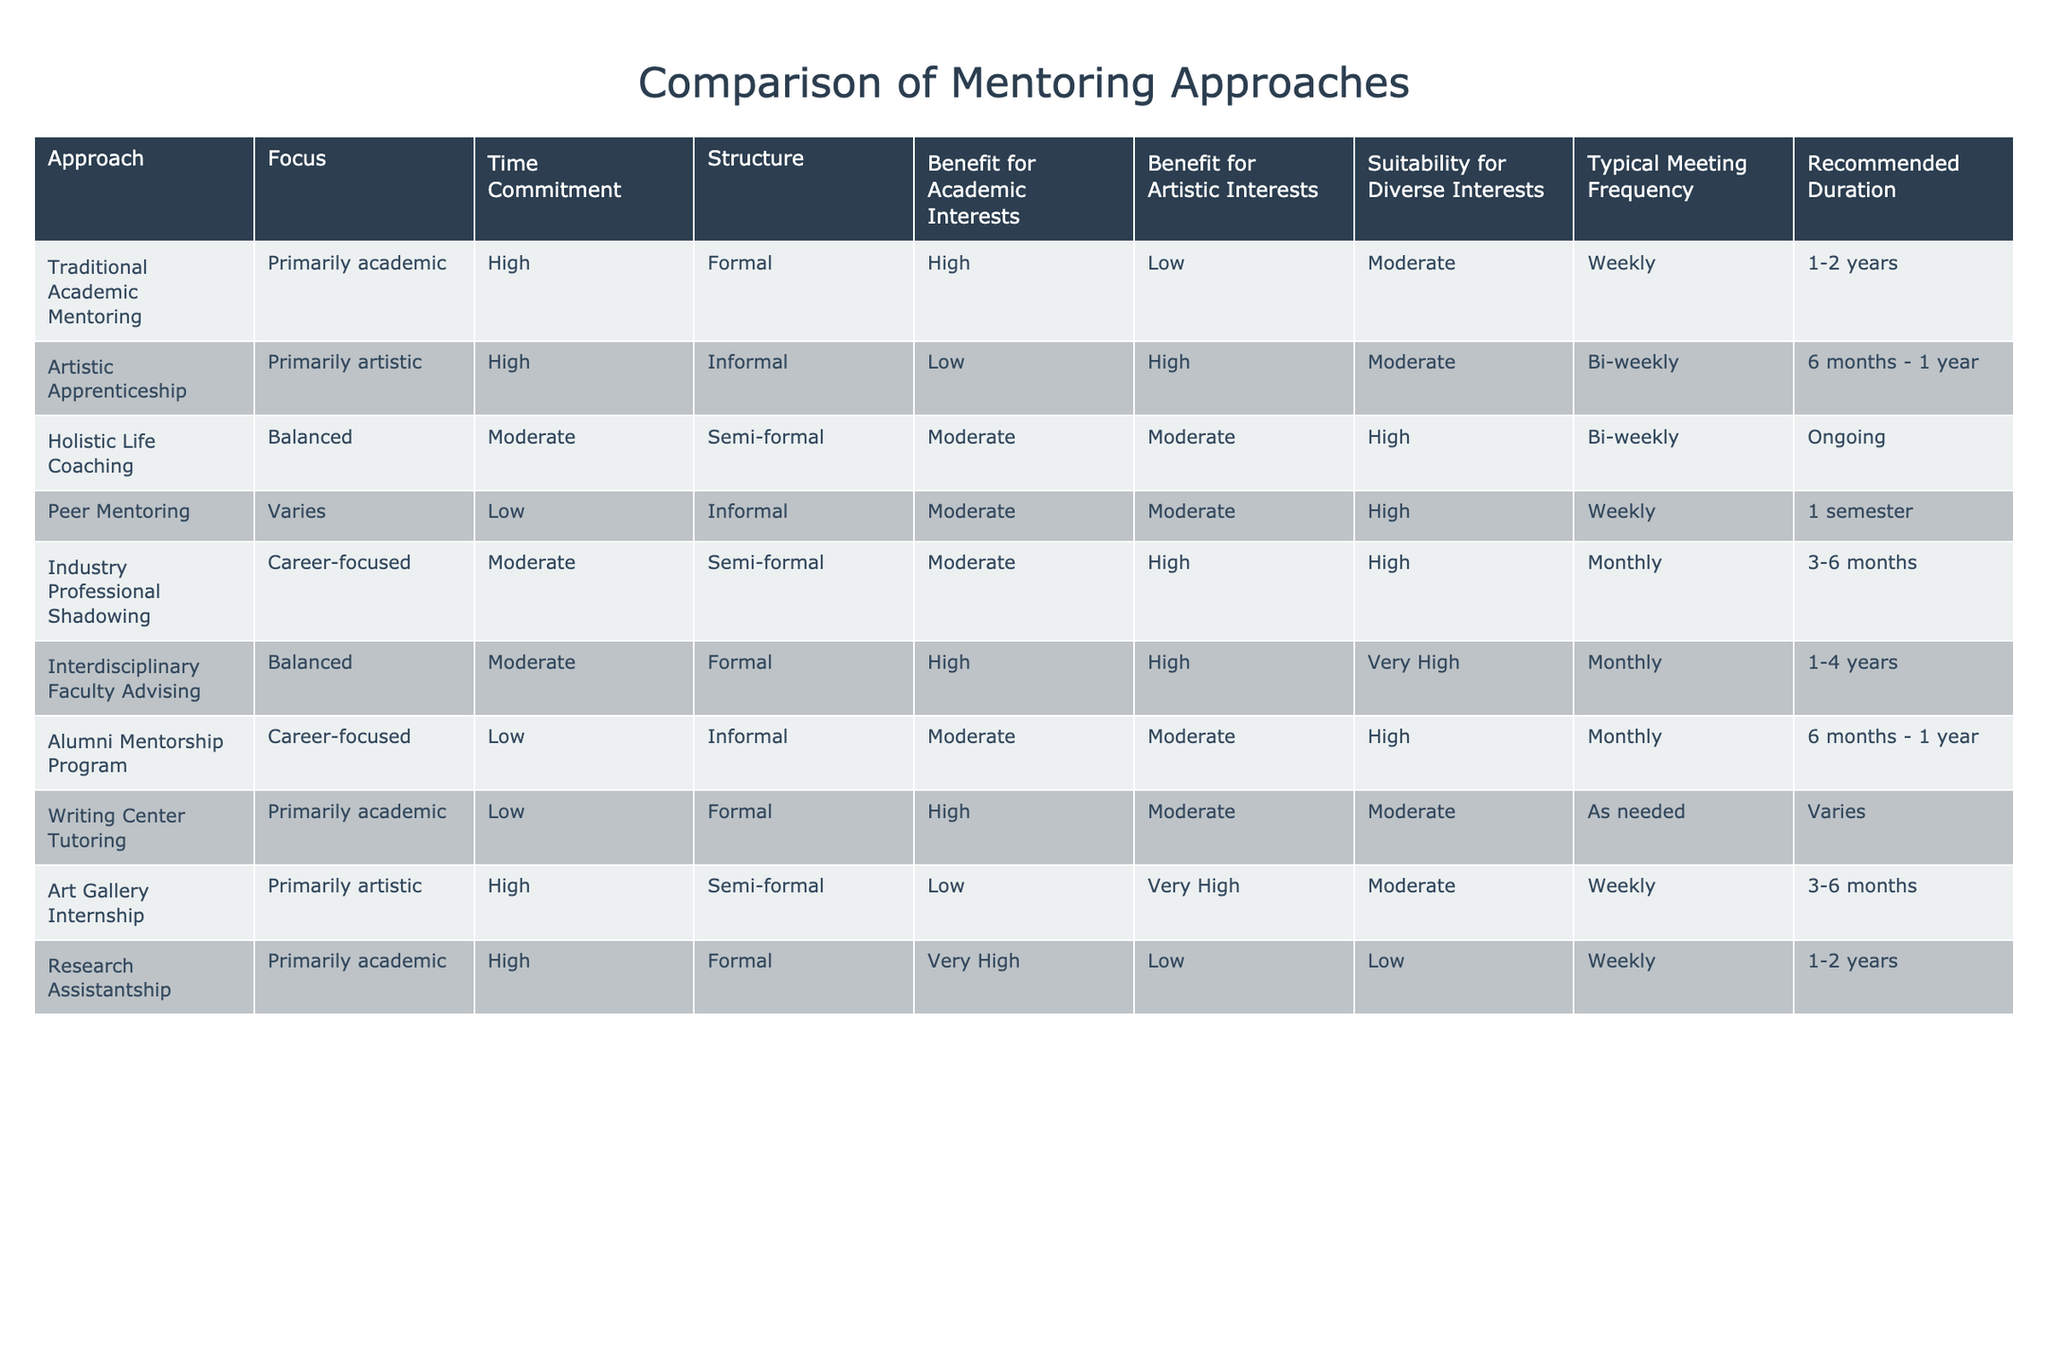What is the typical meeting frequency for Peer Mentoring? Looking at the "Typical Meeting Frequency" column, Peer Mentoring is listed with a frequency of "Weekly."
Answer: Weekly Which mentoring approach has the highest benefit for academic interests? In the "Benefit for Academic Interests" column, Traditional Academic Mentoring and Research Assistantship both have a score of "High," which indicates they are tied for the highest benefit.
Answer: Traditional Academic Mentoring and Research Assistantship Is the Artistic Apprenticeship approach suitable for students with diverse interests? In the "Suitability for Diverse Interests" column, Artistic Apprenticeship is marked as "Moderate," suggesting it is somewhat suitable, but not the most suitable option available.
Answer: Moderate What is the average time commitment for balancing mentoring approaches? Assessing the "Time Commitment" for the balanced approaches – Holistic Life Coaching and Interdisciplinary Faculty Advising, both have a "Moderate" commitment level. Therefore, the average time commitment is moderate since both are equal.
Answer: Moderate True or False: Industry Professional Shadowing is primarily focused on academic interests. By examining the "Focus" column, it shows that Industry Professional Shadowing is categorized as "Career-focused," which is neither primarily academic nor primarily artistic. Thus, the statement is false.
Answer: False Which mentoring approaches provide benefits for both academic and artistic interests? To address this, we look at the columns for "Benefit for Academic Interests" and "Benefit for Artistic Interests." The approaches that have at least a "Moderate" or higher score in both columns are Holistic Life Coaching and Interdisciplinary Faculty Advising.
Answer: Holistic Life Coaching and Interdisciplinary Faculty Advising What mentoring approach has the lowest benefit for academic interests and the highest benefit for artistic interests? Review the table for the rows with "Low" under "Benefit for Academic Interests," which includes Artistic Apprenticeship and Research Assistantship. However, Artistic Apprenticeship has a "High" score in the artistic category while Research Assistantship has a "Low." Thus, the only approach meeting these criteria is Artistic Apprenticeship.
Answer: Artistic Apprenticeship How many mentoring approaches have a formal structure and high benefit for academic interests? From the table, we see both Traditional Academic Mentoring and Research Assistantship have a "Formal" structure and "High" in academic benefits, counting these gives us two approaches that meet both criteria.
Answer: 2 